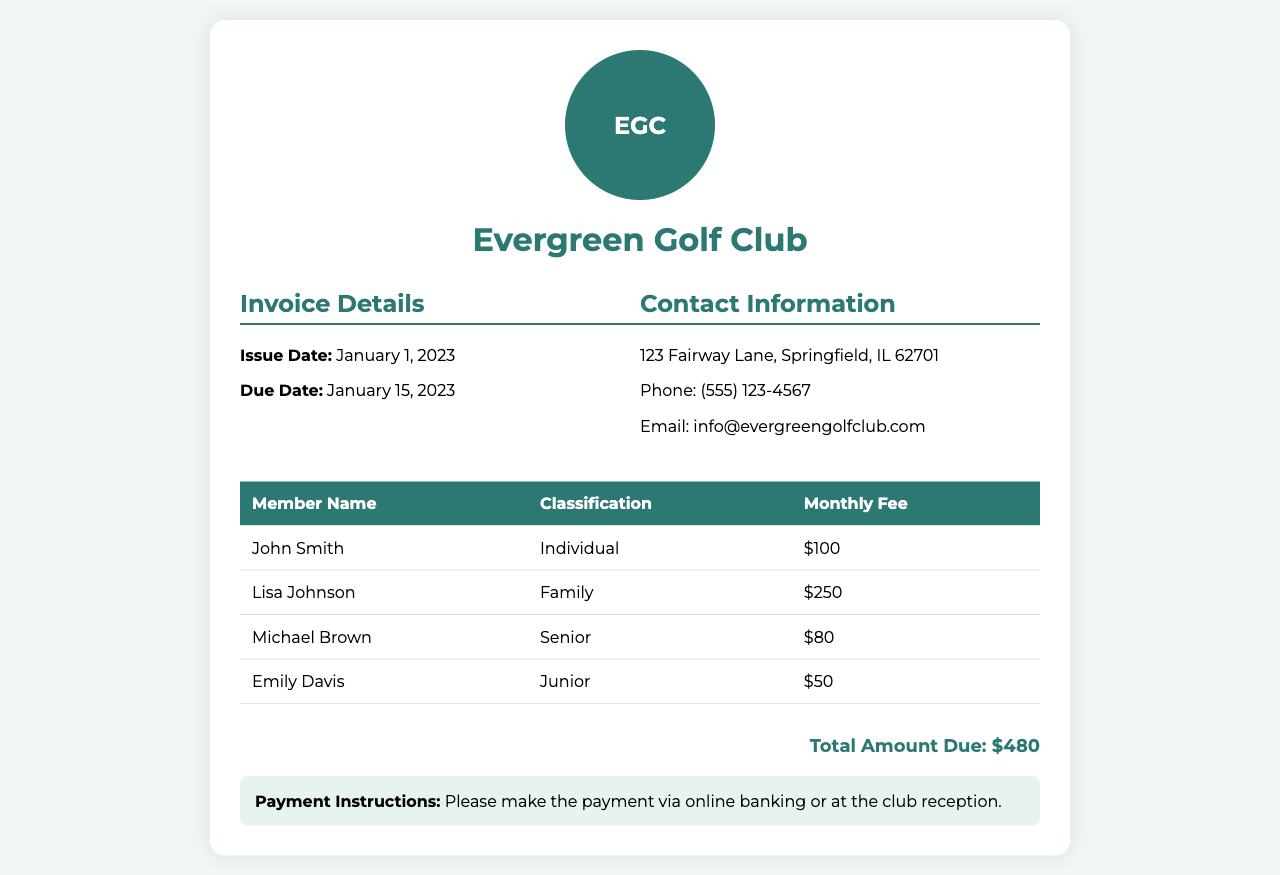what is the invoice issue date? The invoice issue date is provided in the document, which is January 1, 2023.
Answer: January 1, 2023 what is the total amount due? The total amount due is calculated from the individual member fees listed, totaling $480.
Answer: $480 who is the member classified as Senior? The document lists Michael Brown as the member classified under the Senior category.
Answer: Michael Brown how much does a Junior member pay? The monthly fee for a Junior member is specified as $50 in the invoice.
Answer: $50 what is the address of the club? The club's contact information provides the address which is 123 Fairway Lane, Springfield, IL 62701.
Answer: 123 Fairway Lane, Springfield, IL 62701 how many family members are charged under the Family classification? The document indicates that the Family classification includes Lisa Johnson, whose fee is $250.
Answer: 1 what payment methods are accepted? The payment instructions mention using online banking or paying at the club reception.
Answer: online banking or at the club reception what is the classification of Emily Davis? Emily Davis is classified as a Junior member in the document.
Answer: Junior what is the phone number listed for the club? The contact information includes a phone number which is (555) 123-4567.
Answer: (555) 123-4567 